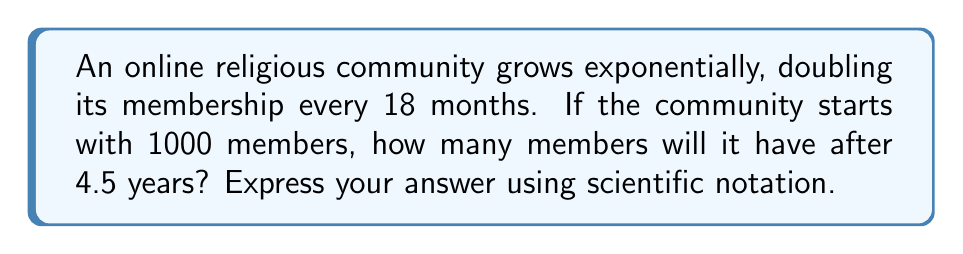Show me your answer to this math problem. Let's approach this step-by-step:

1) First, we need to set up our exponential growth function. The general form is:

   $A(t) = A_0 \cdot (1 + r)^t$

   Where $A(t)$ is the amount after time $t$, $A_0$ is the initial amount, and $r$ is the growth rate.

2) We know the community doubles every 18 months, so:

   $2 = (1 + r)^3$  (since 18 months = 1.5 years)

3) Solving for $r$:

   $\sqrt[3]{2} = 1 + r$
   $r = \sqrt[3]{2} - 1 \approx 0.2599$ or about 26% per 6-month period

4) Now we can set up our function:

   $A(t) = 1000 \cdot (1.2599)^t$

   Where $t$ is measured in 6-month periods.

5) We want to know the membership after 4.5 years, which is 9 six-month periods.

6) Plugging in $t = 9$:

   $A(9) = 1000 \cdot (1.2599)^9$

7) Using a calculator:

   $A(9) = 1000 \cdot 7.9784 = 7978.4$

8) Rounding to the nearest whole number and expressing in scientific notation:

   $7.98 \times 10^3$

This growth rate aligns with the exponential nature of online community expansion, which a computer science major might find intriguing from a data analysis perspective.
Answer: $7.98 \times 10^3$ 